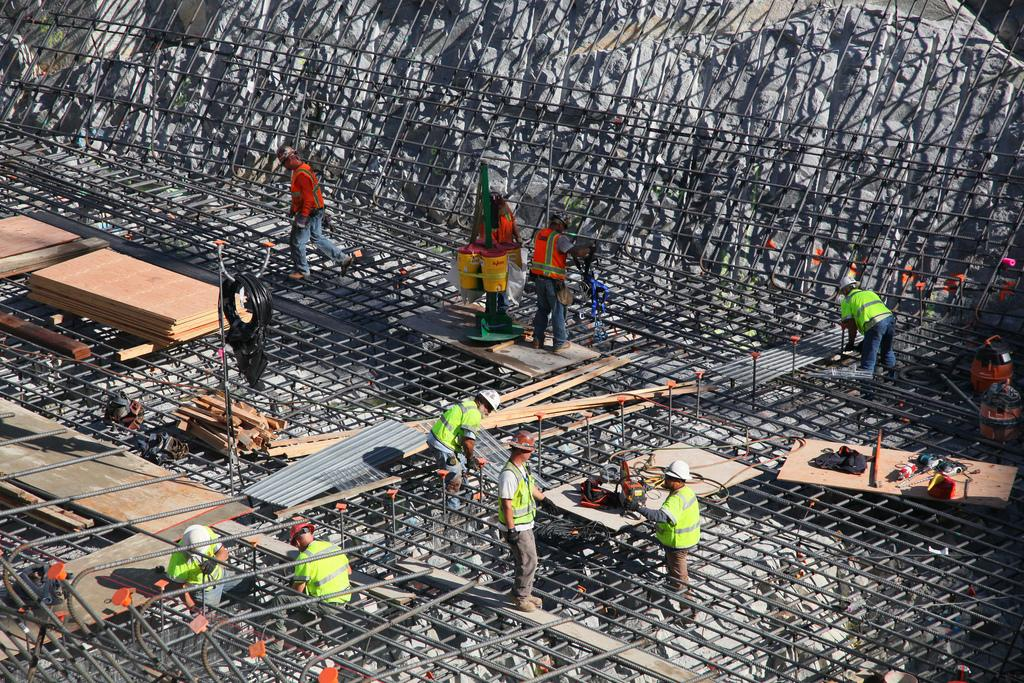What is happening in the center of the image? There are people in the center of the image, and they are working. What can be seen on the left side of the image? There are wooden pieces on the left side of the image. What is surrounding the area in the image? There is a net surrounding the area in the image. How many frogs can be seen jumping in the sea in the image? There is no sea or frogs present in the image. 